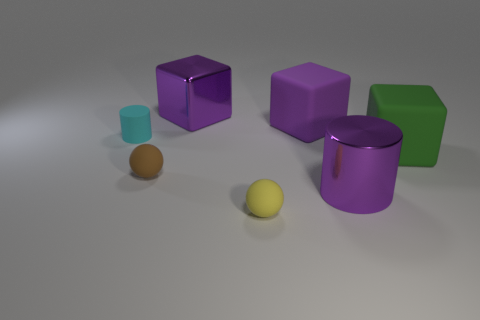Subtract all blue spheres. How many purple cubes are left? 2 Add 1 purple matte things. How many objects exist? 8 Subtract all large matte blocks. How many blocks are left? 1 Subtract 1 cubes. How many cubes are left? 2 Subtract all cylinders. How many objects are left? 5 Subtract all blue cubes. Subtract all red cylinders. How many cubes are left? 3 Subtract 0 green cylinders. How many objects are left? 7 Subtract all brown matte spheres. Subtract all purple metal objects. How many objects are left? 4 Add 7 brown objects. How many brown objects are left? 8 Add 3 small shiny cylinders. How many small shiny cylinders exist? 3 